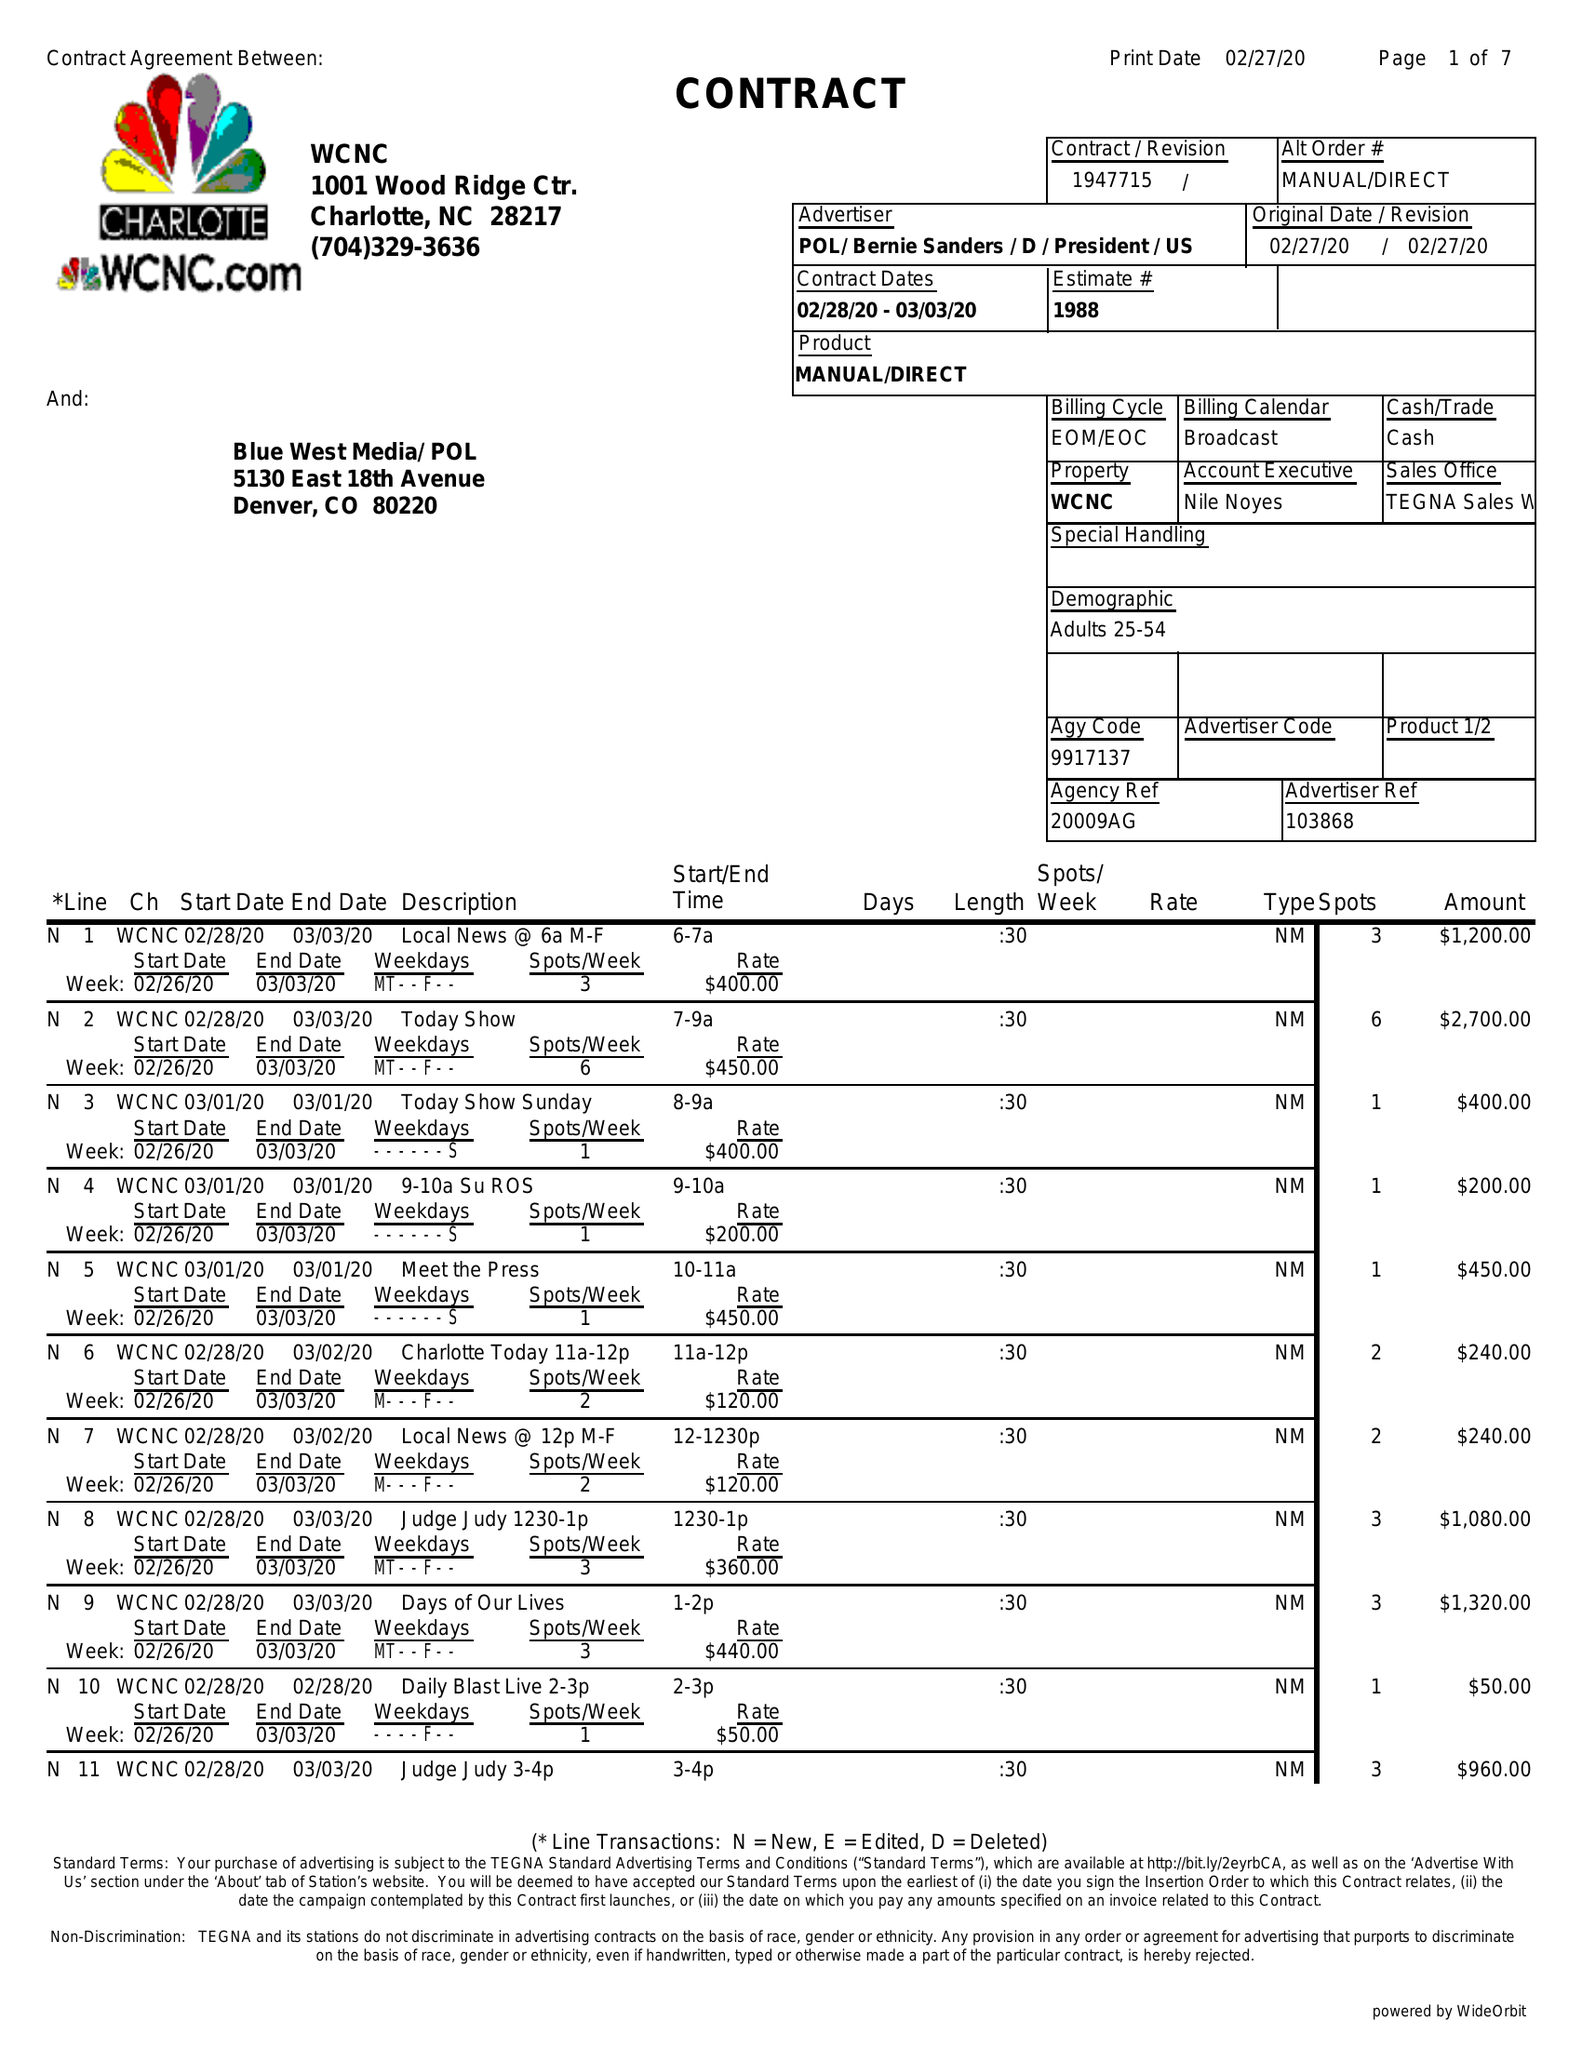What is the value for the gross_amount?
Answer the question using a single word or phrase. 19180.00 